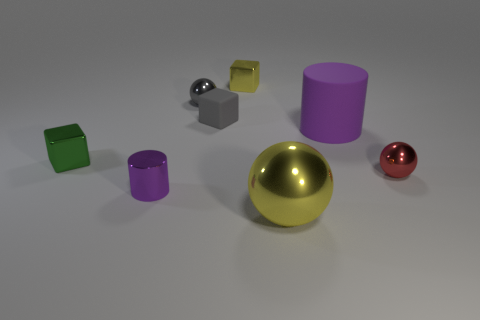Subtract all red balls. How many balls are left? 2 Add 1 rubber cylinders. How many objects exist? 9 Subtract 2 cubes. How many cubes are left? 1 Subtract all gray balls. How many balls are left? 2 Subtract all cylinders. How many objects are left? 6 Subtract all brown metallic cubes. Subtract all red objects. How many objects are left? 7 Add 5 tiny purple metallic cylinders. How many tiny purple metallic cylinders are left? 6 Add 2 large green metal things. How many large green metal things exist? 2 Subtract 0 purple spheres. How many objects are left? 8 Subtract all yellow cylinders. Subtract all purple spheres. How many cylinders are left? 2 